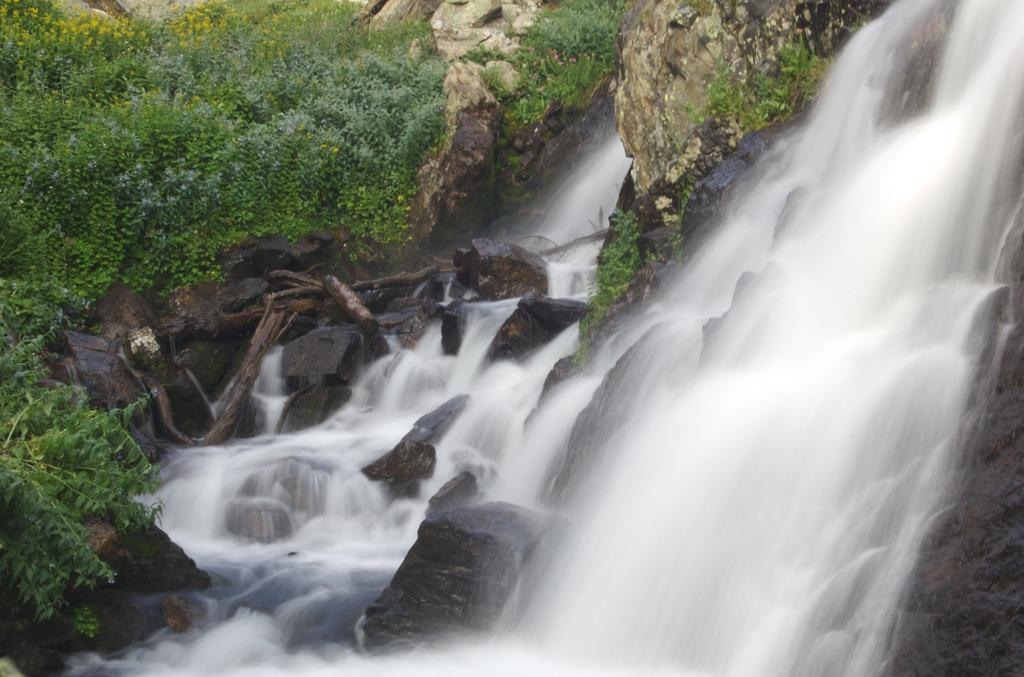What type of geographical feature is present in the image? There are rocky mountains in the image. What can be seen growing on the mountains? There are trees and plants on the mountains. What natural feature is present on the rocks to the right? There is a waterfall on the rocks to the right. What else can be seen on the mountains besides trees and plants? There are tree trunks on the mountains. How many babies are holding onto the string in the image? There are no babies or strings present in the image. What type of wine is being served at the waterfall in the image? There is no wine present in the image; it features a waterfall on the rocks. 